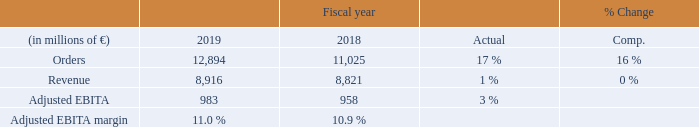Orders at Mobility grew to a record high on a sharp increase in volume from large orders, which the Strategic Company won across the businesses, most notably in the rolling stock and the customer services businesses. Among the major contract wins were a € 1.6 billion order for metro trains in the U. K., a € 1.2 billion contract for high-speed trains including maintenance in Russia, a € 0.8 billion order for trainsets including service in Canada, a € 0.7 billion contract for diesel-electric locomotives including a service agreement in the U. S. and two orders in Germany worth € 0.4 billion and € 0.3 billion, respectively, for regional multiple-unit trainsets. In fiscal 2018, Mobility also gained a number of significant contracts across the regions.
Revenue grew slightly as double-digit growth in the customer services business was largely offset by a decline in the rail infrastructure business. Revenue in the rolling stock business remained close to the prior-year level due to unfavorable timing effects related to the execution of large rail projects, which the business began to ramp up late in the fiscal year. Mobility continued to operate with high profitability in fiscal 2019, including a strong contribution to Adjusted EBITA from the services business. Severance charges were € 20 million, up from € 14 million in fiscal 2018. Mobility’s order backlog was € 33 billion at the end of the fiscal year, of which € 8 billion are expected to be converted into revenue in fiscal 2020.
Order growth reflected overall strong markets for Mobility in fiscal 2019, with different dynamics among the regions. Market development in Europe was characterized by continuing awards of mid-size and large orders, particularly in the U. K., Germany and Austria. Within the C. I. S., large projects for high-speed trains and services were awarded in Russia. Demand in the Middle East and Africa was held back by ongoing uncertainties related to budget constraints and political climates. In the Americas region, stable investment activities were driven by demand for mainline
and urban transport, especially in the U. S. and Canada.
Within the Asia, Australia region, Chinese markets saw ongoing investments in high-speed trains, urban transport, freight logistics and rail infrastructure, while India continues to invest in modernizing the country’s transportation infrastructure. For fiscal 2020, we expect markets served by Mobility to grow moderately with increasing demand for digital solutions. Overall, rail transport and intermodal mobility solutions are expected to remain a focus as urbanization continues to progress around the world. In emerging countries, rising incomes are expected to result in greater demand for public transport solutions.
What was the reason for the increase in the Orders at Mobility? Grew to a record high on a sharp increase in volume from large orders, which the strategic company won across the businesses, most notably in the rolling stock and the customer services businesses. What was the reason for the increase in the Revenue? Revenue grew slightly as double-digit growth in the customer services business was largely offset by a decline in the rail infrastructure business. What were the Severance charges in 2019?
Answer scale should be: million. 20. What was the average orders for 2019 and 2018?
Answer scale should be: million. (12,894 + 11,025) / 2
Answer: 11959.5. What it the increase / (decrease) in revenue from 2018 to 2019?
Answer scale should be: million. 8,916 - 8,821
Answer: 95. What is the increase / (decrease) in the Adjusted EBITDA margin from 2018 to 2019?
Answer scale should be: percent. 11.0% - 10.9%
Answer: 0.1. 